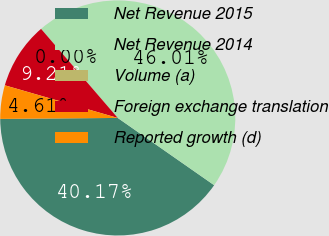Convert chart to OTSL. <chart><loc_0><loc_0><loc_500><loc_500><pie_chart><fcel>Net Revenue 2015<fcel>Net Revenue 2014<fcel>Volume (a)<fcel>Foreign exchange translation<fcel>Reported growth (d)<nl><fcel>40.17%<fcel>46.01%<fcel>0.0%<fcel>9.21%<fcel>4.61%<nl></chart> 